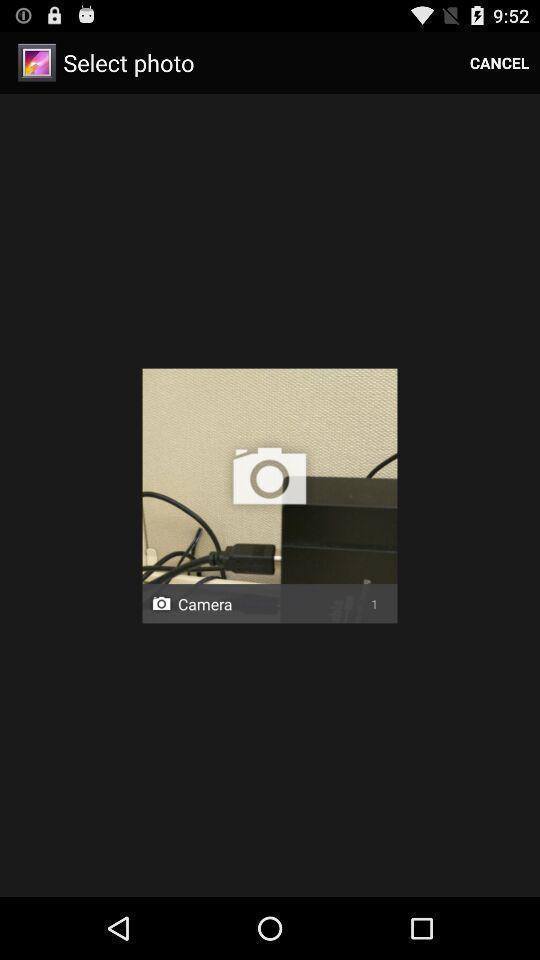Provide a detailed account of this screenshot. Screen shows select photo with image. 